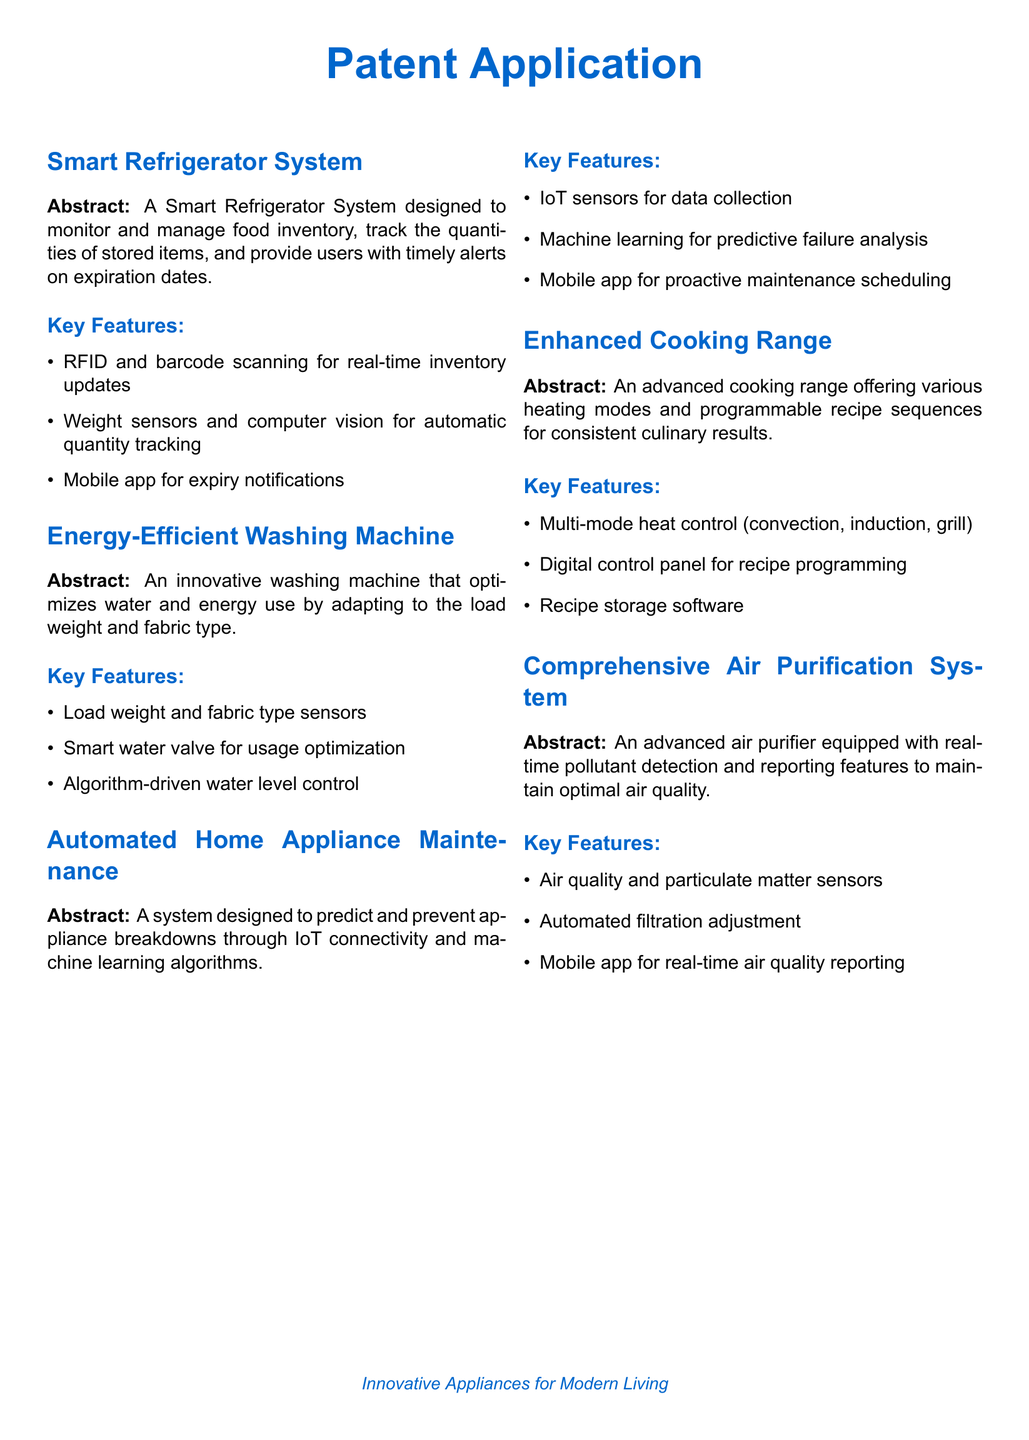What is the main functionality of the Smart Refrigerator System? The main functionality is to monitor and manage food inventory, track quantities, and provide alerts on expiration dates.
Answer: Monitor and manage food inventory How does the Energy-Efficient Washing Machine optimize water usage? It optimizes water usage by adapting to the load weight and fabric type.
Answer: Adapting to load weight and fabric type What technology does the Automated Home Appliance Maintenance System use for predictive analysis? It leverages IoT connectivity and machine learning algorithms for predictive analysis.
Answer: IoT connectivity and machine learning What types of heat control does the Enhanced Cooking Range offer? It offers multi-mode heat control options such as convection, induction, and grill.
Answer: Convection, induction, grill What feature does the Comprehensive Air Purification System include for air quality monitoring? The system includes air quality and particulate matter sensors for monitoring.
Answer: Air quality and particulate matter sensors What is a key feature of the Smart Refrigerator System that facilitates inventory updates? A key feature is RFID and barcode scanning for real-time inventory updates.
Answer: RFID and barcode scanning How does the Automated Home Appliance Maintenance System assist users? It assists users by offering a mobile app for proactive maintenance scheduling.
Answer: Mobile app for proactive maintenance scheduling What modes are available in the Enhanced Cooking Range for culinary results? Available modes include various heating modes and programmable recipe sequences.
Answer: Various heating modes and programmable recipe sequences What does the Comprehensive Air Purification System do in response to pollutants? It automatically adjusts filtration settings in response to detected pollutants.
Answer: Automatically adjusts filtration settings 